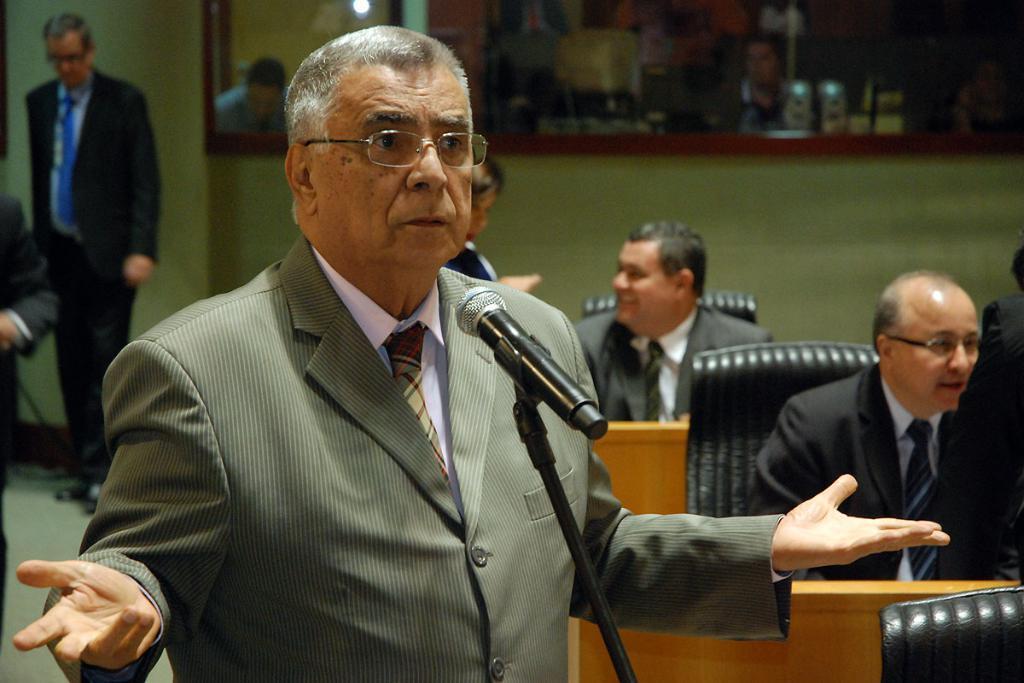How would you summarize this image in a sentence or two? In this image there is one person standing in middle of this image is wearing specs and there is two persons standing at left side of this image, and there is one mirror at top of this image. There are some persons sitting at right side to this image, There is one person at top right side of this image, and there are some objects kept at top right corner of this image,and there are black color chairs at right side of this image. 